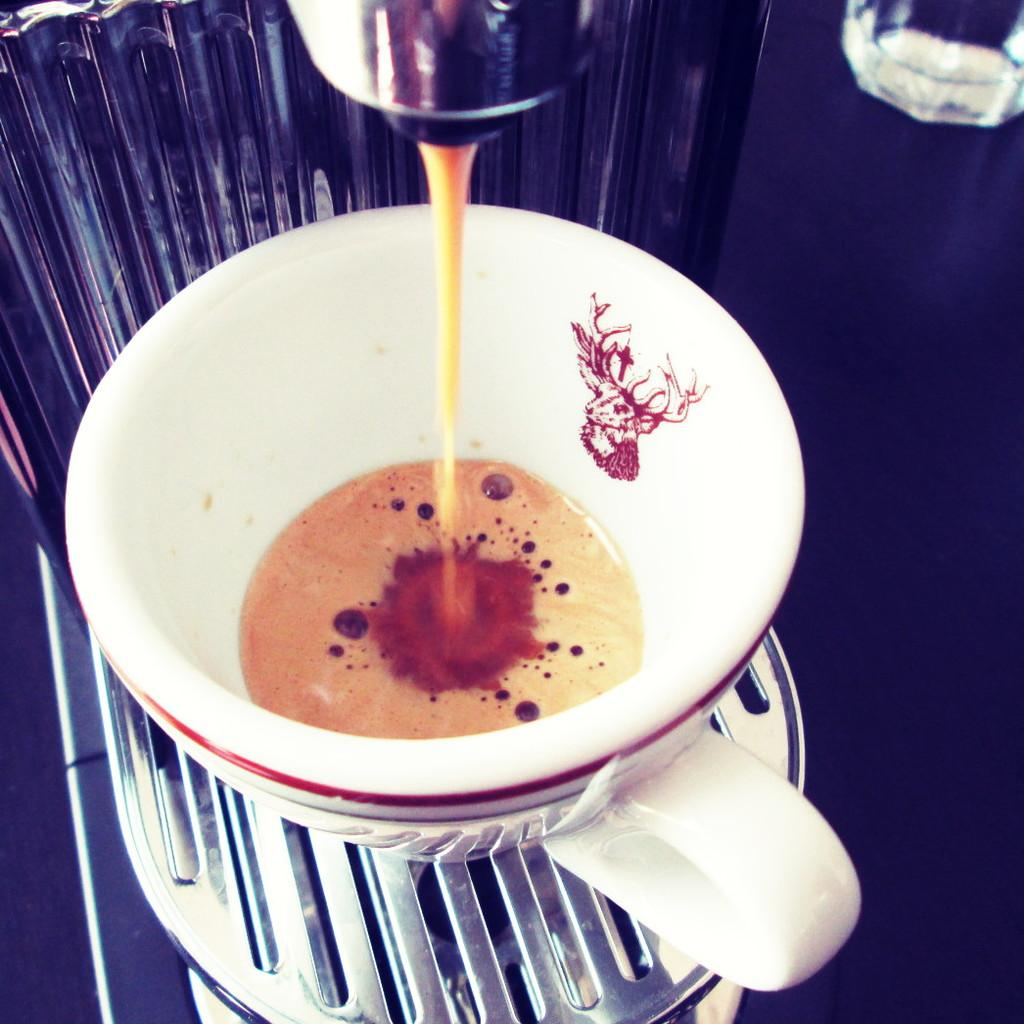What is present in the image that can hold liquid? There is a cup in the image that can hold liquid. Is there anything else related to the cup in the image? Yes, there is an object associated with the cup. What type of liquid can be seen in the cup? There is some liquid in the cup. What type of error can be seen in the image? There is no error present in the image; it is a simple image of a cup with some liquid in it. Can you tell me how many geese are visible in the image? There are no geese present in the image. 